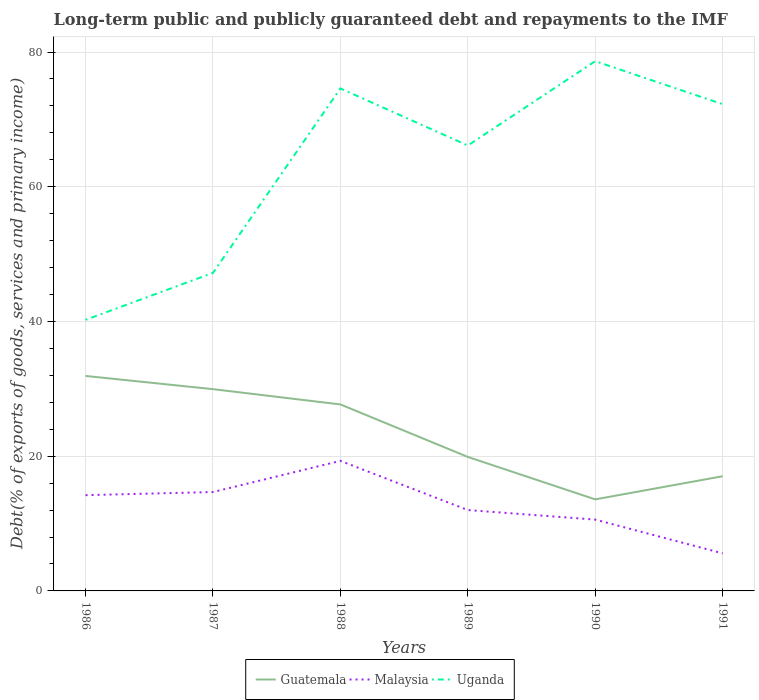How many different coloured lines are there?
Offer a terse response. 3. Does the line corresponding to Malaysia intersect with the line corresponding to Uganda?
Ensure brevity in your answer.  No. Across all years, what is the maximum debt and repayments in Guatemala?
Give a very brief answer. 13.59. In which year was the debt and repayments in Malaysia maximum?
Offer a terse response. 1991. What is the total debt and repayments in Guatemala in the graph?
Offer a very short reply. -3.43. What is the difference between the highest and the second highest debt and repayments in Uganda?
Your answer should be very brief. 38.4. What is the difference between the highest and the lowest debt and repayments in Malaysia?
Your answer should be very brief. 3. Is the debt and repayments in Guatemala strictly greater than the debt and repayments in Malaysia over the years?
Your response must be concise. No. How many years are there in the graph?
Ensure brevity in your answer.  6. Are the values on the major ticks of Y-axis written in scientific E-notation?
Give a very brief answer. No. Does the graph contain any zero values?
Provide a succinct answer. No. Does the graph contain grids?
Make the answer very short. Yes. Where does the legend appear in the graph?
Give a very brief answer. Bottom center. How many legend labels are there?
Provide a short and direct response. 3. How are the legend labels stacked?
Your response must be concise. Horizontal. What is the title of the graph?
Your answer should be very brief. Long-term public and publicly guaranteed debt and repayments to the IMF. Does "Turkey" appear as one of the legend labels in the graph?
Your answer should be compact. No. What is the label or title of the X-axis?
Ensure brevity in your answer.  Years. What is the label or title of the Y-axis?
Your response must be concise. Debt(% of exports of goods, services and primary income). What is the Debt(% of exports of goods, services and primary income) in Guatemala in 1986?
Give a very brief answer. 31.91. What is the Debt(% of exports of goods, services and primary income) in Malaysia in 1986?
Provide a short and direct response. 14.22. What is the Debt(% of exports of goods, services and primary income) of Uganda in 1986?
Make the answer very short. 40.24. What is the Debt(% of exports of goods, services and primary income) in Guatemala in 1987?
Ensure brevity in your answer.  29.95. What is the Debt(% of exports of goods, services and primary income) of Malaysia in 1987?
Make the answer very short. 14.68. What is the Debt(% of exports of goods, services and primary income) of Uganda in 1987?
Make the answer very short. 47.21. What is the Debt(% of exports of goods, services and primary income) in Guatemala in 1988?
Give a very brief answer. 27.68. What is the Debt(% of exports of goods, services and primary income) in Malaysia in 1988?
Give a very brief answer. 19.3. What is the Debt(% of exports of goods, services and primary income) in Uganda in 1988?
Provide a short and direct response. 74.6. What is the Debt(% of exports of goods, services and primary income) in Guatemala in 1989?
Ensure brevity in your answer.  19.89. What is the Debt(% of exports of goods, services and primary income) of Malaysia in 1989?
Provide a short and direct response. 12. What is the Debt(% of exports of goods, services and primary income) of Uganda in 1989?
Keep it short and to the point. 66.12. What is the Debt(% of exports of goods, services and primary income) of Guatemala in 1990?
Offer a very short reply. 13.59. What is the Debt(% of exports of goods, services and primary income) of Malaysia in 1990?
Give a very brief answer. 10.59. What is the Debt(% of exports of goods, services and primary income) of Uganda in 1990?
Offer a very short reply. 78.64. What is the Debt(% of exports of goods, services and primary income) in Guatemala in 1991?
Make the answer very short. 17.02. What is the Debt(% of exports of goods, services and primary income) in Malaysia in 1991?
Your answer should be compact. 5.58. What is the Debt(% of exports of goods, services and primary income) in Uganda in 1991?
Offer a terse response. 72.26. Across all years, what is the maximum Debt(% of exports of goods, services and primary income) of Guatemala?
Your answer should be compact. 31.91. Across all years, what is the maximum Debt(% of exports of goods, services and primary income) in Malaysia?
Keep it short and to the point. 19.3. Across all years, what is the maximum Debt(% of exports of goods, services and primary income) in Uganda?
Provide a short and direct response. 78.64. Across all years, what is the minimum Debt(% of exports of goods, services and primary income) in Guatemala?
Ensure brevity in your answer.  13.59. Across all years, what is the minimum Debt(% of exports of goods, services and primary income) of Malaysia?
Offer a terse response. 5.58. Across all years, what is the minimum Debt(% of exports of goods, services and primary income) of Uganda?
Your response must be concise. 40.24. What is the total Debt(% of exports of goods, services and primary income) in Guatemala in the graph?
Make the answer very short. 140.06. What is the total Debt(% of exports of goods, services and primary income) in Malaysia in the graph?
Make the answer very short. 76.37. What is the total Debt(% of exports of goods, services and primary income) in Uganda in the graph?
Your answer should be compact. 379.07. What is the difference between the Debt(% of exports of goods, services and primary income) of Guatemala in 1986 and that in 1987?
Provide a succinct answer. 1.96. What is the difference between the Debt(% of exports of goods, services and primary income) in Malaysia in 1986 and that in 1987?
Provide a succinct answer. -0.46. What is the difference between the Debt(% of exports of goods, services and primary income) in Uganda in 1986 and that in 1987?
Your answer should be compact. -6.97. What is the difference between the Debt(% of exports of goods, services and primary income) of Guatemala in 1986 and that in 1988?
Keep it short and to the point. 4.23. What is the difference between the Debt(% of exports of goods, services and primary income) of Malaysia in 1986 and that in 1988?
Make the answer very short. -5.09. What is the difference between the Debt(% of exports of goods, services and primary income) of Uganda in 1986 and that in 1988?
Provide a short and direct response. -34.35. What is the difference between the Debt(% of exports of goods, services and primary income) of Guatemala in 1986 and that in 1989?
Your answer should be compact. 12.02. What is the difference between the Debt(% of exports of goods, services and primary income) in Malaysia in 1986 and that in 1989?
Your answer should be compact. 2.21. What is the difference between the Debt(% of exports of goods, services and primary income) in Uganda in 1986 and that in 1989?
Offer a terse response. -25.88. What is the difference between the Debt(% of exports of goods, services and primary income) in Guatemala in 1986 and that in 1990?
Keep it short and to the point. 18.32. What is the difference between the Debt(% of exports of goods, services and primary income) in Malaysia in 1986 and that in 1990?
Ensure brevity in your answer.  3.63. What is the difference between the Debt(% of exports of goods, services and primary income) in Uganda in 1986 and that in 1990?
Provide a succinct answer. -38.4. What is the difference between the Debt(% of exports of goods, services and primary income) in Guatemala in 1986 and that in 1991?
Provide a short and direct response. 14.89. What is the difference between the Debt(% of exports of goods, services and primary income) of Malaysia in 1986 and that in 1991?
Offer a terse response. 8.64. What is the difference between the Debt(% of exports of goods, services and primary income) in Uganda in 1986 and that in 1991?
Make the answer very short. -32.02. What is the difference between the Debt(% of exports of goods, services and primary income) of Guatemala in 1987 and that in 1988?
Provide a succinct answer. 2.27. What is the difference between the Debt(% of exports of goods, services and primary income) of Malaysia in 1987 and that in 1988?
Your response must be concise. -4.63. What is the difference between the Debt(% of exports of goods, services and primary income) in Uganda in 1987 and that in 1988?
Provide a succinct answer. -27.39. What is the difference between the Debt(% of exports of goods, services and primary income) in Guatemala in 1987 and that in 1989?
Provide a succinct answer. 10.06. What is the difference between the Debt(% of exports of goods, services and primary income) of Malaysia in 1987 and that in 1989?
Offer a very short reply. 2.67. What is the difference between the Debt(% of exports of goods, services and primary income) in Uganda in 1987 and that in 1989?
Ensure brevity in your answer.  -18.91. What is the difference between the Debt(% of exports of goods, services and primary income) in Guatemala in 1987 and that in 1990?
Ensure brevity in your answer.  16.36. What is the difference between the Debt(% of exports of goods, services and primary income) of Malaysia in 1987 and that in 1990?
Your answer should be compact. 4.09. What is the difference between the Debt(% of exports of goods, services and primary income) in Uganda in 1987 and that in 1990?
Provide a succinct answer. -31.43. What is the difference between the Debt(% of exports of goods, services and primary income) in Guatemala in 1987 and that in 1991?
Offer a terse response. 12.93. What is the difference between the Debt(% of exports of goods, services and primary income) of Malaysia in 1987 and that in 1991?
Provide a succinct answer. 9.1. What is the difference between the Debt(% of exports of goods, services and primary income) of Uganda in 1987 and that in 1991?
Keep it short and to the point. -25.05. What is the difference between the Debt(% of exports of goods, services and primary income) in Guatemala in 1988 and that in 1989?
Make the answer very short. 7.79. What is the difference between the Debt(% of exports of goods, services and primary income) in Malaysia in 1988 and that in 1989?
Give a very brief answer. 7.3. What is the difference between the Debt(% of exports of goods, services and primary income) of Uganda in 1988 and that in 1989?
Your answer should be very brief. 8.48. What is the difference between the Debt(% of exports of goods, services and primary income) in Guatemala in 1988 and that in 1990?
Give a very brief answer. 14.09. What is the difference between the Debt(% of exports of goods, services and primary income) of Malaysia in 1988 and that in 1990?
Give a very brief answer. 8.72. What is the difference between the Debt(% of exports of goods, services and primary income) in Uganda in 1988 and that in 1990?
Ensure brevity in your answer.  -4.04. What is the difference between the Debt(% of exports of goods, services and primary income) of Guatemala in 1988 and that in 1991?
Give a very brief answer. 10.66. What is the difference between the Debt(% of exports of goods, services and primary income) in Malaysia in 1988 and that in 1991?
Your answer should be very brief. 13.73. What is the difference between the Debt(% of exports of goods, services and primary income) in Uganda in 1988 and that in 1991?
Your response must be concise. 2.34. What is the difference between the Debt(% of exports of goods, services and primary income) in Guatemala in 1989 and that in 1990?
Provide a short and direct response. 6.3. What is the difference between the Debt(% of exports of goods, services and primary income) in Malaysia in 1989 and that in 1990?
Offer a very short reply. 1.42. What is the difference between the Debt(% of exports of goods, services and primary income) of Uganda in 1989 and that in 1990?
Give a very brief answer. -12.52. What is the difference between the Debt(% of exports of goods, services and primary income) in Guatemala in 1989 and that in 1991?
Your answer should be very brief. 2.87. What is the difference between the Debt(% of exports of goods, services and primary income) in Malaysia in 1989 and that in 1991?
Make the answer very short. 6.43. What is the difference between the Debt(% of exports of goods, services and primary income) of Uganda in 1989 and that in 1991?
Provide a short and direct response. -6.14. What is the difference between the Debt(% of exports of goods, services and primary income) in Guatemala in 1990 and that in 1991?
Your answer should be very brief. -3.43. What is the difference between the Debt(% of exports of goods, services and primary income) of Malaysia in 1990 and that in 1991?
Offer a terse response. 5.01. What is the difference between the Debt(% of exports of goods, services and primary income) of Uganda in 1990 and that in 1991?
Give a very brief answer. 6.38. What is the difference between the Debt(% of exports of goods, services and primary income) in Guatemala in 1986 and the Debt(% of exports of goods, services and primary income) in Malaysia in 1987?
Your answer should be very brief. 17.23. What is the difference between the Debt(% of exports of goods, services and primary income) in Guatemala in 1986 and the Debt(% of exports of goods, services and primary income) in Uganda in 1987?
Offer a very short reply. -15.3. What is the difference between the Debt(% of exports of goods, services and primary income) in Malaysia in 1986 and the Debt(% of exports of goods, services and primary income) in Uganda in 1987?
Keep it short and to the point. -32.99. What is the difference between the Debt(% of exports of goods, services and primary income) in Guatemala in 1986 and the Debt(% of exports of goods, services and primary income) in Malaysia in 1988?
Your response must be concise. 12.61. What is the difference between the Debt(% of exports of goods, services and primary income) in Guatemala in 1986 and the Debt(% of exports of goods, services and primary income) in Uganda in 1988?
Ensure brevity in your answer.  -42.68. What is the difference between the Debt(% of exports of goods, services and primary income) in Malaysia in 1986 and the Debt(% of exports of goods, services and primary income) in Uganda in 1988?
Keep it short and to the point. -60.38. What is the difference between the Debt(% of exports of goods, services and primary income) in Guatemala in 1986 and the Debt(% of exports of goods, services and primary income) in Malaysia in 1989?
Ensure brevity in your answer.  19.91. What is the difference between the Debt(% of exports of goods, services and primary income) of Guatemala in 1986 and the Debt(% of exports of goods, services and primary income) of Uganda in 1989?
Ensure brevity in your answer.  -34.21. What is the difference between the Debt(% of exports of goods, services and primary income) in Malaysia in 1986 and the Debt(% of exports of goods, services and primary income) in Uganda in 1989?
Make the answer very short. -51.9. What is the difference between the Debt(% of exports of goods, services and primary income) in Guatemala in 1986 and the Debt(% of exports of goods, services and primary income) in Malaysia in 1990?
Make the answer very short. 21.33. What is the difference between the Debt(% of exports of goods, services and primary income) of Guatemala in 1986 and the Debt(% of exports of goods, services and primary income) of Uganda in 1990?
Your response must be concise. -46.73. What is the difference between the Debt(% of exports of goods, services and primary income) in Malaysia in 1986 and the Debt(% of exports of goods, services and primary income) in Uganda in 1990?
Keep it short and to the point. -64.42. What is the difference between the Debt(% of exports of goods, services and primary income) of Guatemala in 1986 and the Debt(% of exports of goods, services and primary income) of Malaysia in 1991?
Your response must be concise. 26.33. What is the difference between the Debt(% of exports of goods, services and primary income) in Guatemala in 1986 and the Debt(% of exports of goods, services and primary income) in Uganda in 1991?
Offer a very short reply. -40.34. What is the difference between the Debt(% of exports of goods, services and primary income) in Malaysia in 1986 and the Debt(% of exports of goods, services and primary income) in Uganda in 1991?
Provide a succinct answer. -58.04. What is the difference between the Debt(% of exports of goods, services and primary income) in Guatemala in 1987 and the Debt(% of exports of goods, services and primary income) in Malaysia in 1988?
Offer a very short reply. 10.65. What is the difference between the Debt(% of exports of goods, services and primary income) in Guatemala in 1987 and the Debt(% of exports of goods, services and primary income) in Uganda in 1988?
Your answer should be compact. -44.64. What is the difference between the Debt(% of exports of goods, services and primary income) of Malaysia in 1987 and the Debt(% of exports of goods, services and primary income) of Uganda in 1988?
Provide a short and direct response. -59.92. What is the difference between the Debt(% of exports of goods, services and primary income) of Guatemala in 1987 and the Debt(% of exports of goods, services and primary income) of Malaysia in 1989?
Offer a terse response. 17.95. What is the difference between the Debt(% of exports of goods, services and primary income) in Guatemala in 1987 and the Debt(% of exports of goods, services and primary income) in Uganda in 1989?
Your answer should be compact. -36.17. What is the difference between the Debt(% of exports of goods, services and primary income) in Malaysia in 1987 and the Debt(% of exports of goods, services and primary income) in Uganda in 1989?
Provide a succinct answer. -51.44. What is the difference between the Debt(% of exports of goods, services and primary income) of Guatemala in 1987 and the Debt(% of exports of goods, services and primary income) of Malaysia in 1990?
Your answer should be compact. 19.37. What is the difference between the Debt(% of exports of goods, services and primary income) of Guatemala in 1987 and the Debt(% of exports of goods, services and primary income) of Uganda in 1990?
Provide a succinct answer. -48.69. What is the difference between the Debt(% of exports of goods, services and primary income) in Malaysia in 1987 and the Debt(% of exports of goods, services and primary income) in Uganda in 1990?
Give a very brief answer. -63.96. What is the difference between the Debt(% of exports of goods, services and primary income) of Guatemala in 1987 and the Debt(% of exports of goods, services and primary income) of Malaysia in 1991?
Provide a succinct answer. 24.37. What is the difference between the Debt(% of exports of goods, services and primary income) of Guatemala in 1987 and the Debt(% of exports of goods, services and primary income) of Uganda in 1991?
Provide a succinct answer. -42.3. What is the difference between the Debt(% of exports of goods, services and primary income) in Malaysia in 1987 and the Debt(% of exports of goods, services and primary income) in Uganda in 1991?
Keep it short and to the point. -57.58. What is the difference between the Debt(% of exports of goods, services and primary income) in Guatemala in 1988 and the Debt(% of exports of goods, services and primary income) in Malaysia in 1989?
Ensure brevity in your answer.  15.68. What is the difference between the Debt(% of exports of goods, services and primary income) of Guatemala in 1988 and the Debt(% of exports of goods, services and primary income) of Uganda in 1989?
Give a very brief answer. -38.44. What is the difference between the Debt(% of exports of goods, services and primary income) of Malaysia in 1988 and the Debt(% of exports of goods, services and primary income) of Uganda in 1989?
Provide a short and direct response. -46.82. What is the difference between the Debt(% of exports of goods, services and primary income) of Guatemala in 1988 and the Debt(% of exports of goods, services and primary income) of Malaysia in 1990?
Your answer should be very brief. 17.1. What is the difference between the Debt(% of exports of goods, services and primary income) in Guatemala in 1988 and the Debt(% of exports of goods, services and primary income) in Uganda in 1990?
Give a very brief answer. -50.95. What is the difference between the Debt(% of exports of goods, services and primary income) of Malaysia in 1988 and the Debt(% of exports of goods, services and primary income) of Uganda in 1990?
Keep it short and to the point. -59.33. What is the difference between the Debt(% of exports of goods, services and primary income) of Guatemala in 1988 and the Debt(% of exports of goods, services and primary income) of Malaysia in 1991?
Ensure brevity in your answer.  22.11. What is the difference between the Debt(% of exports of goods, services and primary income) in Guatemala in 1988 and the Debt(% of exports of goods, services and primary income) in Uganda in 1991?
Your answer should be very brief. -44.57. What is the difference between the Debt(% of exports of goods, services and primary income) in Malaysia in 1988 and the Debt(% of exports of goods, services and primary income) in Uganda in 1991?
Give a very brief answer. -52.95. What is the difference between the Debt(% of exports of goods, services and primary income) of Guatemala in 1989 and the Debt(% of exports of goods, services and primary income) of Malaysia in 1990?
Provide a short and direct response. 9.3. What is the difference between the Debt(% of exports of goods, services and primary income) in Guatemala in 1989 and the Debt(% of exports of goods, services and primary income) in Uganda in 1990?
Offer a very short reply. -58.75. What is the difference between the Debt(% of exports of goods, services and primary income) of Malaysia in 1989 and the Debt(% of exports of goods, services and primary income) of Uganda in 1990?
Ensure brevity in your answer.  -66.63. What is the difference between the Debt(% of exports of goods, services and primary income) in Guatemala in 1989 and the Debt(% of exports of goods, services and primary income) in Malaysia in 1991?
Offer a very short reply. 14.31. What is the difference between the Debt(% of exports of goods, services and primary income) in Guatemala in 1989 and the Debt(% of exports of goods, services and primary income) in Uganda in 1991?
Keep it short and to the point. -52.37. What is the difference between the Debt(% of exports of goods, services and primary income) in Malaysia in 1989 and the Debt(% of exports of goods, services and primary income) in Uganda in 1991?
Provide a succinct answer. -60.25. What is the difference between the Debt(% of exports of goods, services and primary income) of Guatemala in 1990 and the Debt(% of exports of goods, services and primary income) of Malaysia in 1991?
Keep it short and to the point. 8.01. What is the difference between the Debt(% of exports of goods, services and primary income) in Guatemala in 1990 and the Debt(% of exports of goods, services and primary income) in Uganda in 1991?
Ensure brevity in your answer.  -58.67. What is the difference between the Debt(% of exports of goods, services and primary income) of Malaysia in 1990 and the Debt(% of exports of goods, services and primary income) of Uganda in 1991?
Provide a short and direct response. -61.67. What is the average Debt(% of exports of goods, services and primary income) of Guatemala per year?
Your response must be concise. 23.34. What is the average Debt(% of exports of goods, services and primary income) of Malaysia per year?
Give a very brief answer. 12.73. What is the average Debt(% of exports of goods, services and primary income) in Uganda per year?
Your response must be concise. 63.18. In the year 1986, what is the difference between the Debt(% of exports of goods, services and primary income) in Guatemala and Debt(% of exports of goods, services and primary income) in Malaysia?
Ensure brevity in your answer.  17.7. In the year 1986, what is the difference between the Debt(% of exports of goods, services and primary income) of Guatemala and Debt(% of exports of goods, services and primary income) of Uganda?
Provide a short and direct response. -8.33. In the year 1986, what is the difference between the Debt(% of exports of goods, services and primary income) in Malaysia and Debt(% of exports of goods, services and primary income) in Uganda?
Provide a short and direct response. -26.03. In the year 1987, what is the difference between the Debt(% of exports of goods, services and primary income) in Guatemala and Debt(% of exports of goods, services and primary income) in Malaysia?
Your response must be concise. 15.27. In the year 1987, what is the difference between the Debt(% of exports of goods, services and primary income) in Guatemala and Debt(% of exports of goods, services and primary income) in Uganda?
Provide a short and direct response. -17.26. In the year 1987, what is the difference between the Debt(% of exports of goods, services and primary income) of Malaysia and Debt(% of exports of goods, services and primary income) of Uganda?
Offer a very short reply. -32.53. In the year 1988, what is the difference between the Debt(% of exports of goods, services and primary income) in Guatemala and Debt(% of exports of goods, services and primary income) in Malaysia?
Keep it short and to the point. 8.38. In the year 1988, what is the difference between the Debt(% of exports of goods, services and primary income) in Guatemala and Debt(% of exports of goods, services and primary income) in Uganda?
Keep it short and to the point. -46.91. In the year 1988, what is the difference between the Debt(% of exports of goods, services and primary income) in Malaysia and Debt(% of exports of goods, services and primary income) in Uganda?
Your response must be concise. -55.29. In the year 1989, what is the difference between the Debt(% of exports of goods, services and primary income) in Guatemala and Debt(% of exports of goods, services and primary income) in Malaysia?
Ensure brevity in your answer.  7.89. In the year 1989, what is the difference between the Debt(% of exports of goods, services and primary income) in Guatemala and Debt(% of exports of goods, services and primary income) in Uganda?
Offer a very short reply. -46.23. In the year 1989, what is the difference between the Debt(% of exports of goods, services and primary income) of Malaysia and Debt(% of exports of goods, services and primary income) of Uganda?
Give a very brief answer. -54.12. In the year 1990, what is the difference between the Debt(% of exports of goods, services and primary income) in Guatemala and Debt(% of exports of goods, services and primary income) in Malaysia?
Provide a short and direct response. 3. In the year 1990, what is the difference between the Debt(% of exports of goods, services and primary income) in Guatemala and Debt(% of exports of goods, services and primary income) in Uganda?
Provide a succinct answer. -65.05. In the year 1990, what is the difference between the Debt(% of exports of goods, services and primary income) of Malaysia and Debt(% of exports of goods, services and primary income) of Uganda?
Your answer should be compact. -68.05. In the year 1991, what is the difference between the Debt(% of exports of goods, services and primary income) in Guatemala and Debt(% of exports of goods, services and primary income) in Malaysia?
Your answer should be compact. 11.45. In the year 1991, what is the difference between the Debt(% of exports of goods, services and primary income) of Guatemala and Debt(% of exports of goods, services and primary income) of Uganda?
Your answer should be compact. -55.23. In the year 1991, what is the difference between the Debt(% of exports of goods, services and primary income) of Malaysia and Debt(% of exports of goods, services and primary income) of Uganda?
Make the answer very short. -66.68. What is the ratio of the Debt(% of exports of goods, services and primary income) in Guatemala in 1986 to that in 1987?
Offer a very short reply. 1.07. What is the ratio of the Debt(% of exports of goods, services and primary income) of Malaysia in 1986 to that in 1987?
Provide a short and direct response. 0.97. What is the ratio of the Debt(% of exports of goods, services and primary income) in Uganda in 1986 to that in 1987?
Your answer should be compact. 0.85. What is the ratio of the Debt(% of exports of goods, services and primary income) of Guatemala in 1986 to that in 1988?
Your answer should be compact. 1.15. What is the ratio of the Debt(% of exports of goods, services and primary income) in Malaysia in 1986 to that in 1988?
Keep it short and to the point. 0.74. What is the ratio of the Debt(% of exports of goods, services and primary income) of Uganda in 1986 to that in 1988?
Ensure brevity in your answer.  0.54. What is the ratio of the Debt(% of exports of goods, services and primary income) of Guatemala in 1986 to that in 1989?
Offer a terse response. 1.6. What is the ratio of the Debt(% of exports of goods, services and primary income) in Malaysia in 1986 to that in 1989?
Offer a very short reply. 1.18. What is the ratio of the Debt(% of exports of goods, services and primary income) of Uganda in 1986 to that in 1989?
Make the answer very short. 0.61. What is the ratio of the Debt(% of exports of goods, services and primary income) of Guatemala in 1986 to that in 1990?
Give a very brief answer. 2.35. What is the ratio of the Debt(% of exports of goods, services and primary income) of Malaysia in 1986 to that in 1990?
Ensure brevity in your answer.  1.34. What is the ratio of the Debt(% of exports of goods, services and primary income) in Uganda in 1986 to that in 1990?
Give a very brief answer. 0.51. What is the ratio of the Debt(% of exports of goods, services and primary income) of Guatemala in 1986 to that in 1991?
Offer a very short reply. 1.87. What is the ratio of the Debt(% of exports of goods, services and primary income) in Malaysia in 1986 to that in 1991?
Your response must be concise. 2.55. What is the ratio of the Debt(% of exports of goods, services and primary income) in Uganda in 1986 to that in 1991?
Offer a terse response. 0.56. What is the ratio of the Debt(% of exports of goods, services and primary income) in Guatemala in 1987 to that in 1988?
Offer a terse response. 1.08. What is the ratio of the Debt(% of exports of goods, services and primary income) in Malaysia in 1987 to that in 1988?
Your answer should be very brief. 0.76. What is the ratio of the Debt(% of exports of goods, services and primary income) of Uganda in 1987 to that in 1988?
Offer a terse response. 0.63. What is the ratio of the Debt(% of exports of goods, services and primary income) of Guatemala in 1987 to that in 1989?
Your answer should be compact. 1.51. What is the ratio of the Debt(% of exports of goods, services and primary income) of Malaysia in 1987 to that in 1989?
Offer a terse response. 1.22. What is the ratio of the Debt(% of exports of goods, services and primary income) of Uganda in 1987 to that in 1989?
Offer a very short reply. 0.71. What is the ratio of the Debt(% of exports of goods, services and primary income) of Guatemala in 1987 to that in 1990?
Give a very brief answer. 2.2. What is the ratio of the Debt(% of exports of goods, services and primary income) of Malaysia in 1987 to that in 1990?
Keep it short and to the point. 1.39. What is the ratio of the Debt(% of exports of goods, services and primary income) in Uganda in 1987 to that in 1990?
Make the answer very short. 0.6. What is the ratio of the Debt(% of exports of goods, services and primary income) of Guatemala in 1987 to that in 1991?
Offer a very short reply. 1.76. What is the ratio of the Debt(% of exports of goods, services and primary income) of Malaysia in 1987 to that in 1991?
Your answer should be compact. 2.63. What is the ratio of the Debt(% of exports of goods, services and primary income) in Uganda in 1987 to that in 1991?
Make the answer very short. 0.65. What is the ratio of the Debt(% of exports of goods, services and primary income) in Guatemala in 1988 to that in 1989?
Give a very brief answer. 1.39. What is the ratio of the Debt(% of exports of goods, services and primary income) of Malaysia in 1988 to that in 1989?
Your answer should be compact. 1.61. What is the ratio of the Debt(% of exports of goods, services and primary income) of Uganda in 1988 to that in 1989?
Ensure brevity in your answer.  1.13. What is the ratio of the Debt(% of exports of goods, services and primary income) in Guatemala in 1988 to that in 1990?
Your answer should be very brief. 2.04. What is the ratio of the Debt(% of exports of goods, services and primary income) in Malaysia in 1988 to that in 1990?
Your answer should be very brief. 1.82. What is the ratio of the Debt(% of exports of goods, services and primary income) in Uganda in 1988 to that in 1990?
Provide a short and direct response. 0.95. What is the ratio of the Debt(% of exports of goods, services and primary income) in Guatemala in 1988 to that in 1991?
Your answer should be compact. 1.63. What is the ratio of the Debt(% of exports of goods, services and primary income) in Malaysia in 1988 to that in 1991?
Make the answer very short. 3.46. What is the ratio of the Debt(% of exports of goods, services and primary income) of Uganda in 1988 to that in 1991?
Make the answer very short. 1.03. What is the ratio of the Debt(% of exports of goods, services and primary income) of Guatemala in 1989 to that in 1990?
Your response must be concise. 1.46. What is the ratio of the Debt(% of exports of goods, services and primary income) in Malaysia in 1989 to that in 1990?
Offer a terse response. 1.13. What is the ratio of the Debt(% of exports of goods, services and primary income) in Uganda in 1989 to that in 1990?
Provide a short and direct response. 0.84. What is the ratio of the Debt(% of exports of goods, services and primary income) of Guatemala in 1989 to that in 1991?
Provide a short and direct response. 1.17. What is the ratio of the Debt(% of exports of goods, services and primary income) of Malaysia in 1989 to that in 1991?
Provide a short and direct response. 2.15. What is the ratio of the Debt(% of exports of goods, services and primary income) of Uganda in 1989 to that in 1991?
Your answer should be very brief. 0.92. What is the ratio of the Debt(% of exports of goods, services and primary income) in Guatemala in 1990 to that in 1991?
Your answer should be compact. 0.8. What is the ratio of the Debt(% of exports of goods, services and primary income) of Malaysia in 1990 to that in 1991?
Ensure brevity in your answer.  1.9. What is the ratio of the Debt(% of exports of goods, services and primary income) in Uganda in 1990 to that in 1991?
Offer a very short reply. 1.09. What is the difference between the highest and the second highest Debt(% of exports of goods, services and primary income) of Guatemala?
Offer a very short reply. 1.96. What is the difference between the highest and the second highest Debt(% of exports of goods, services and primary income) in Malaysia?
Your answer should be compact. 4.63. What is the difference between the highest and the second highest Debt(% of exports of goods, services and primary income) in Uganda?
Ensure brevity in your answer.  4.04. What is the difference between the highest and the lowest Debt(% of exports of goods, services and primary income) in Guatemala?
Keep it short and to the point. 18.32. What is the difference between the highest and the lowest Debt(% of exports of goods, services and primary income) in Malaysia?
Provide a succinct answer. 13.73. What is the difference between the highest and the lowest Debt(% of exports of goods, services and primary income) of Uganda?
Offer a terse response. 38.4. 